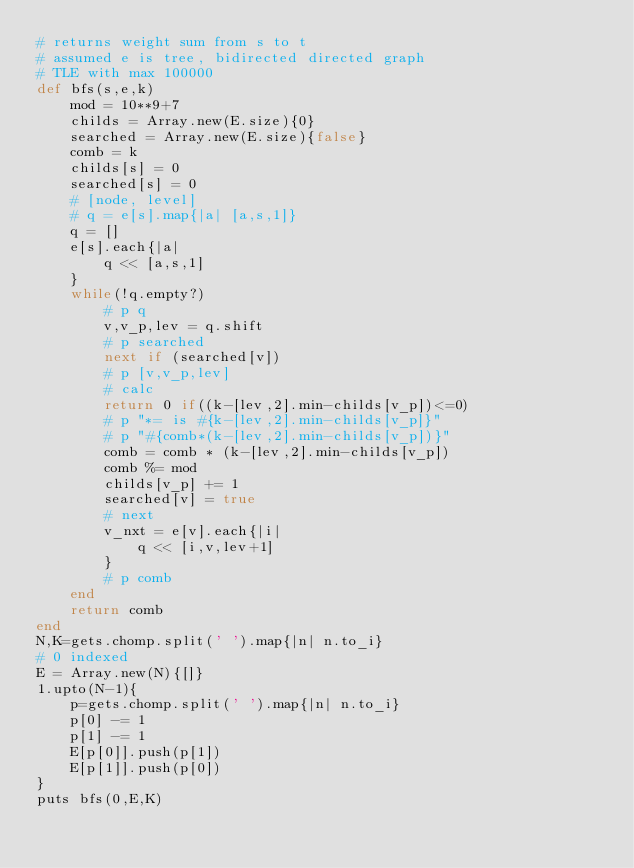Convert code to text. <code><loc_0><loc_0><loc_500><loc_500><_Ruby_># returns weight sum from s to t
# assumed e is tree, bidirected directed graph
# TLE with max 100000
def bfs(s,e,k)
	mod = 10**9+7
	childs = Array.new(E.size){0}
	searched = Array.new(E.size){false}
	comb = k
	childs[s] = 0
	searched[s] = 0
	# [node, level]
	# q = e[s].map{|a| [a,s,1]}
	q = []
	e[s].each{|a| 
		q << [a,s,1]
	}
	while(!q.empty?)
		# p q
		v,v_p,lev = q.shift
		# p searched
		next if (searched[v])
		# p [v,v_p,lev]
		# calc
		return 0 if((k-[lev,2].min-childs[v_p])<=0)
		# p "*= is #{k-[lev,2].min-childs[v_p]}"
		# p "#{comb*(k-[lev,2].min-childs[v_p])}"
		comb = comb * (k-[lev,2].min-childs[v_p])
		comb %= mod
		childs[v_p] += 1		
		searched[v] = true
		# next
		v_nxt = e[v].each{|i| 
			q << [i,v,lev+1]
		}
		# p comb
	end
	return comb
end
N,K=gets.chomp.split(' ').map{|n| n.to_i}
# 0 indexed
E = Array.new(N){[]}
1.upto(N-1){
	p=gets.chomp.split(' ').map{|n| n.to_i}
	p[0] -= 1
	p[1] -= 1
	E[p[0]].push(p[1])
	E[p[1]].push(p[0])
}
puts bfs(0,E,K)
</code> 